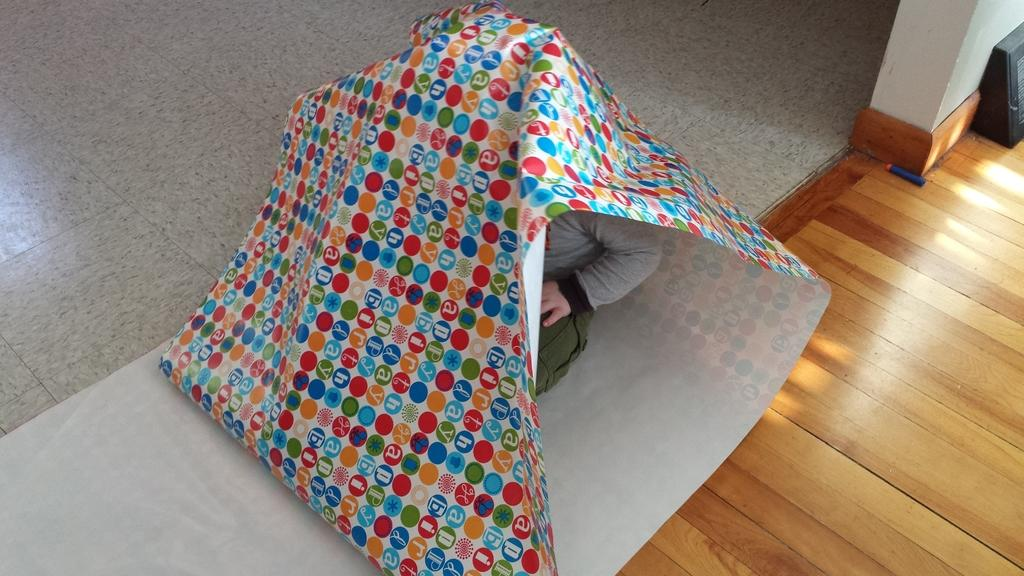What is the person in the image doing? The person is covered under a colorful sheet. What type of surface can be seen in the image? There is a wooden surface in the image. What is the color of the object in the image? The object in the image is black. How many ants can be seen crawling on the person in the image? There are no ants visible in the image; the person is covered under a colorful sheet. What type of butter is being used to spread on the wooden surface in the image? There is no butter present in the image; it only features a person covered under a sheet and a black object on a wooden surface. 